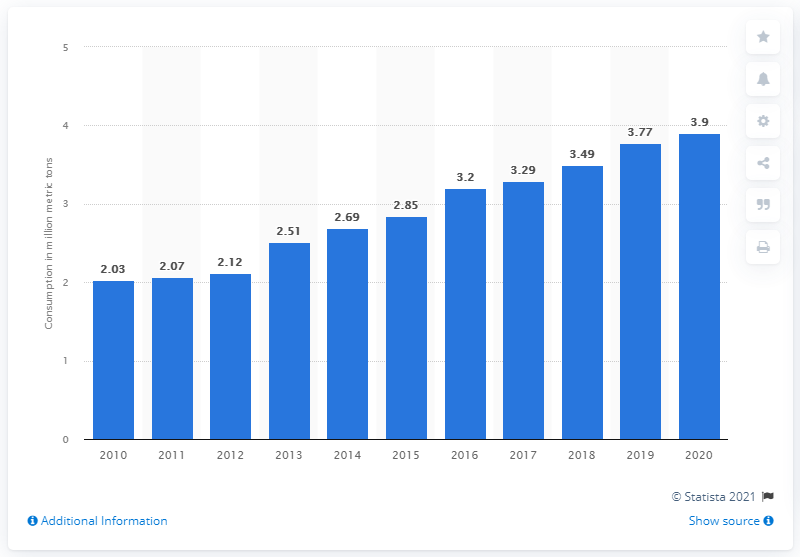Draw attention to some important aspects in this diagram. In 2020, the Brazilian industrial sector consumed an estimated 3.9 million metric tons of soybean oil. In 2020, the Brazilian industrial sector consumed approximately 3.9 million metric tons of soybean oil. 